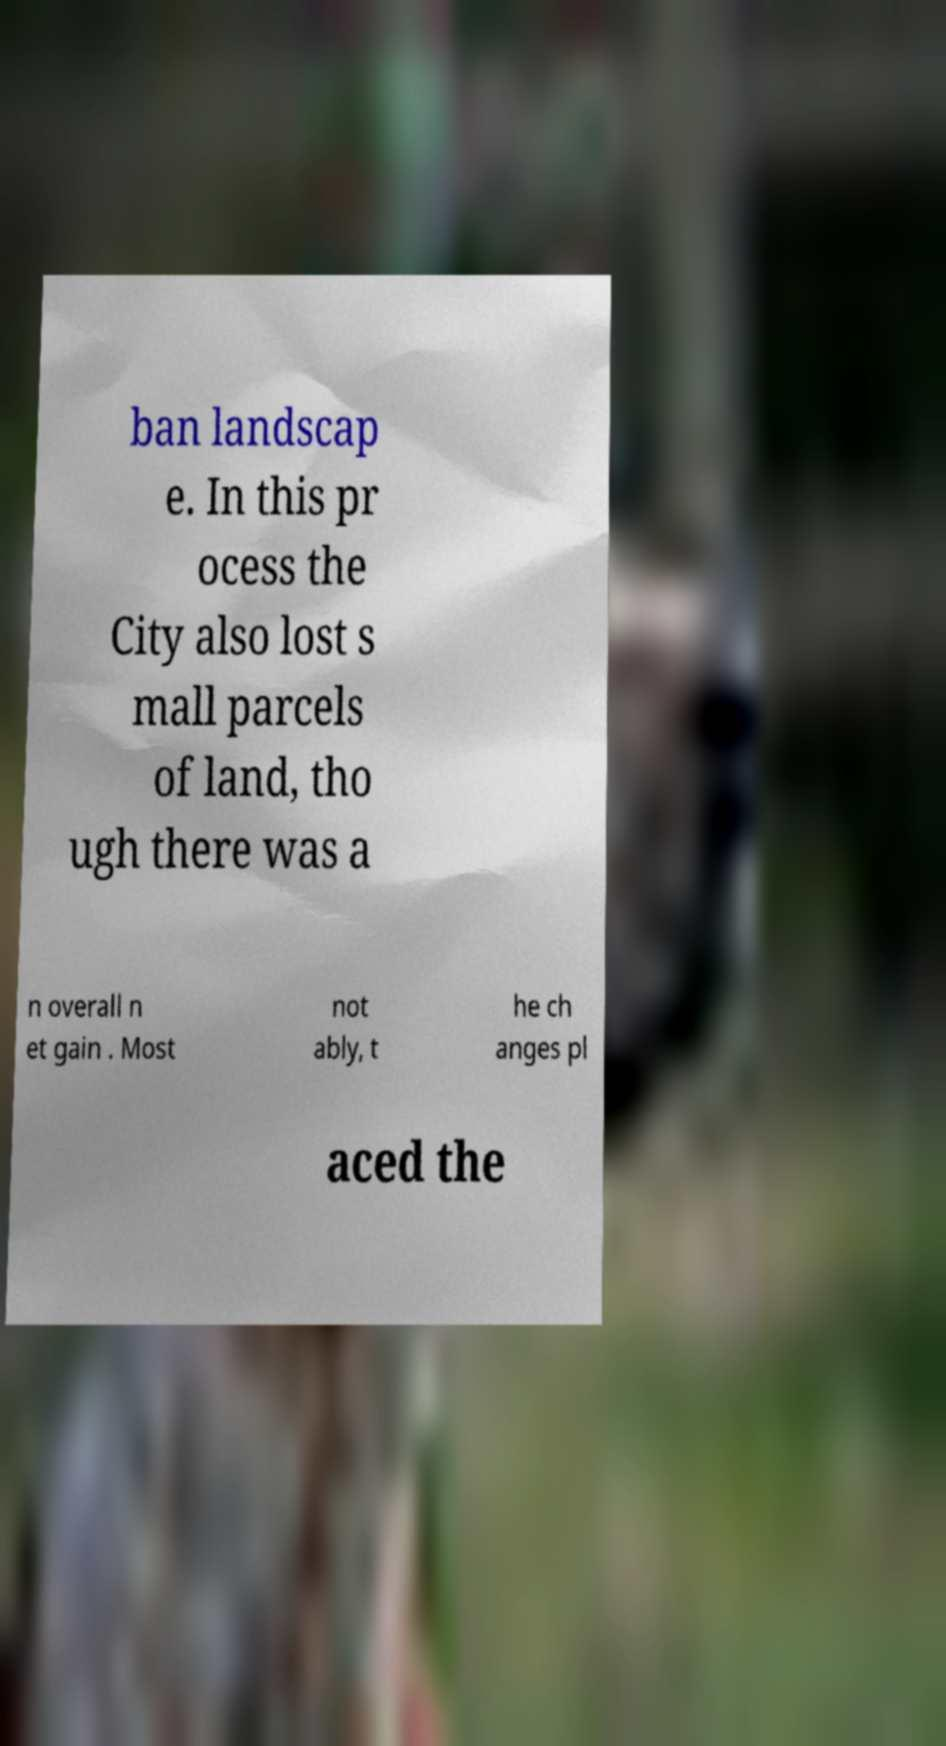Can you read and provide the text displayed in the image?This photo seems to have some interesting text. Can you extract and type it out for me? ban landscap e. In this pr ocess the City also lost s mall parcels of land, tho ugh there was a n overall n et gain . Most not ably, t he ch anges pl aced the 